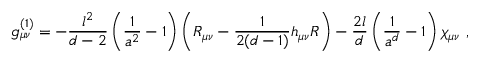Convert formula to latex. <formula><loc_0><loc_0><loc_500><loc_500>g _ { \mu \nu } ^ { ( 1 ) } = - { \frac { l ^ { 2 } } { d - 2 } } \left ( { \frac { 1 } { a ^ { 2 } } } - 1 \right ) \left ( R _ { \mu \nu } - { \frac { 1 } { 2 ( d - 1 ) } } h _ { \mu \nu } R \right ) - { \frac { 2 l } { d } } \left ( { \frac { 1 } { a ^ { d } } } - 1 \right ) \chi _ { \mu \nu } \ ,</formula> 